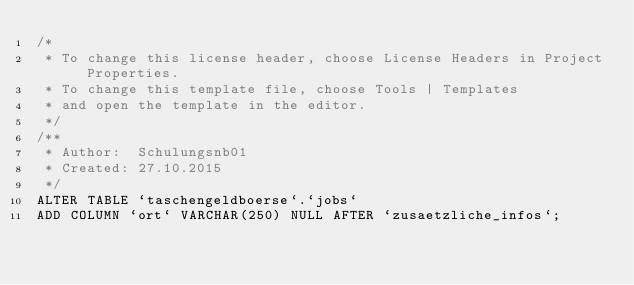<code> <loc_0><loc_0><loc_500><loc_500><_SQL_>/* 
 * To change this license header, choose License Headers in Project Properties.
 * To change this template file, choose Tools | Templates
 * and open the template in the editor.
 */
/**
 * Author:  Schulungsnb01
 * Created: 27.10.2015
 */
ALTER TABLE `taschengeldboerse`.`jobs` 
ADD COLUMN `ort` VARCHAR(250) NULL AFTER `zusaetzliche_infos`;

</code> 